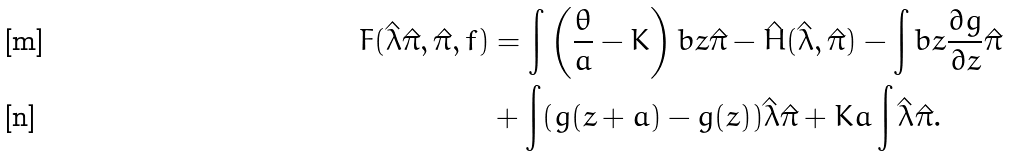Convert formula to latex. <formula><loc_0><loc_0><loc_500><loc_500>F ( \hat { \lambda } \hat { \pi } , \hat { \pi } , f ) & = \int \left ( \frac { \theta } { a } - K \right ) b z \hat { \pi } - \hat { H } ( \hat { \lambda } , \hat { \pi } ) - \int b z \frac { \partial g } { \partial z } \hat { \pi } \\ & + \int ( g ( z + a ) - g ( z ) ) \hat { \lambda } \hat { \pi } + K a \int \hat { \lambda } \hat { \pi } .</formula> 